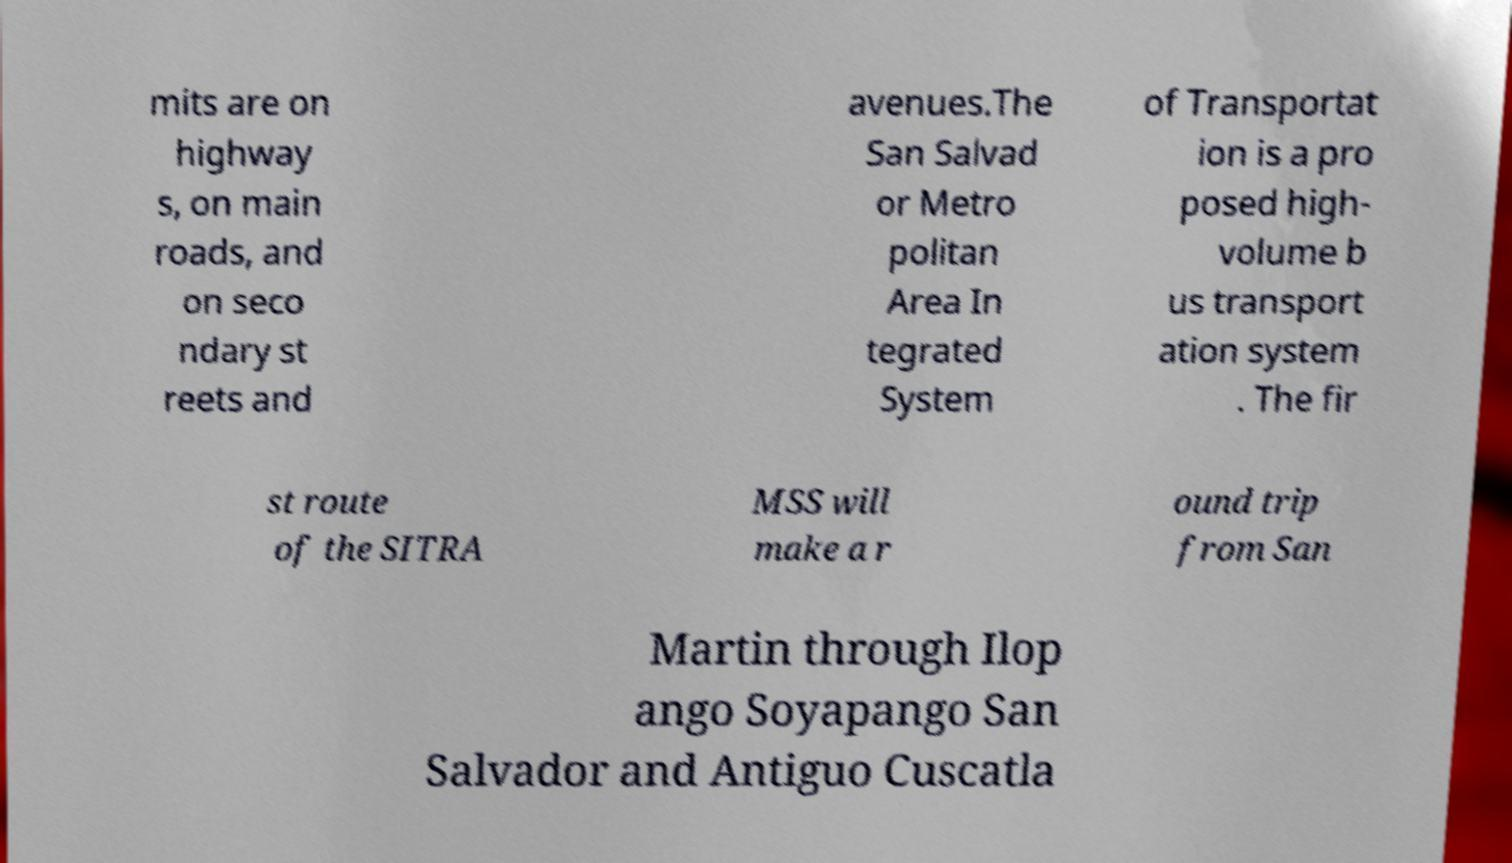What messages or text are displayed in this image? I need them in a readable, typed format. mits are on highway s, on main roads, and on seco ndary st reets and avenues.The San Salvad or Metro politan Area In tegrated System of Transportat ion is a pro posed high- volume b us transport ation system . The fir st route of the SITRA MSS will make a r ound trip from San Martin through Ilop ango Soyapango San Salvador and Antiguo Cuscatla 